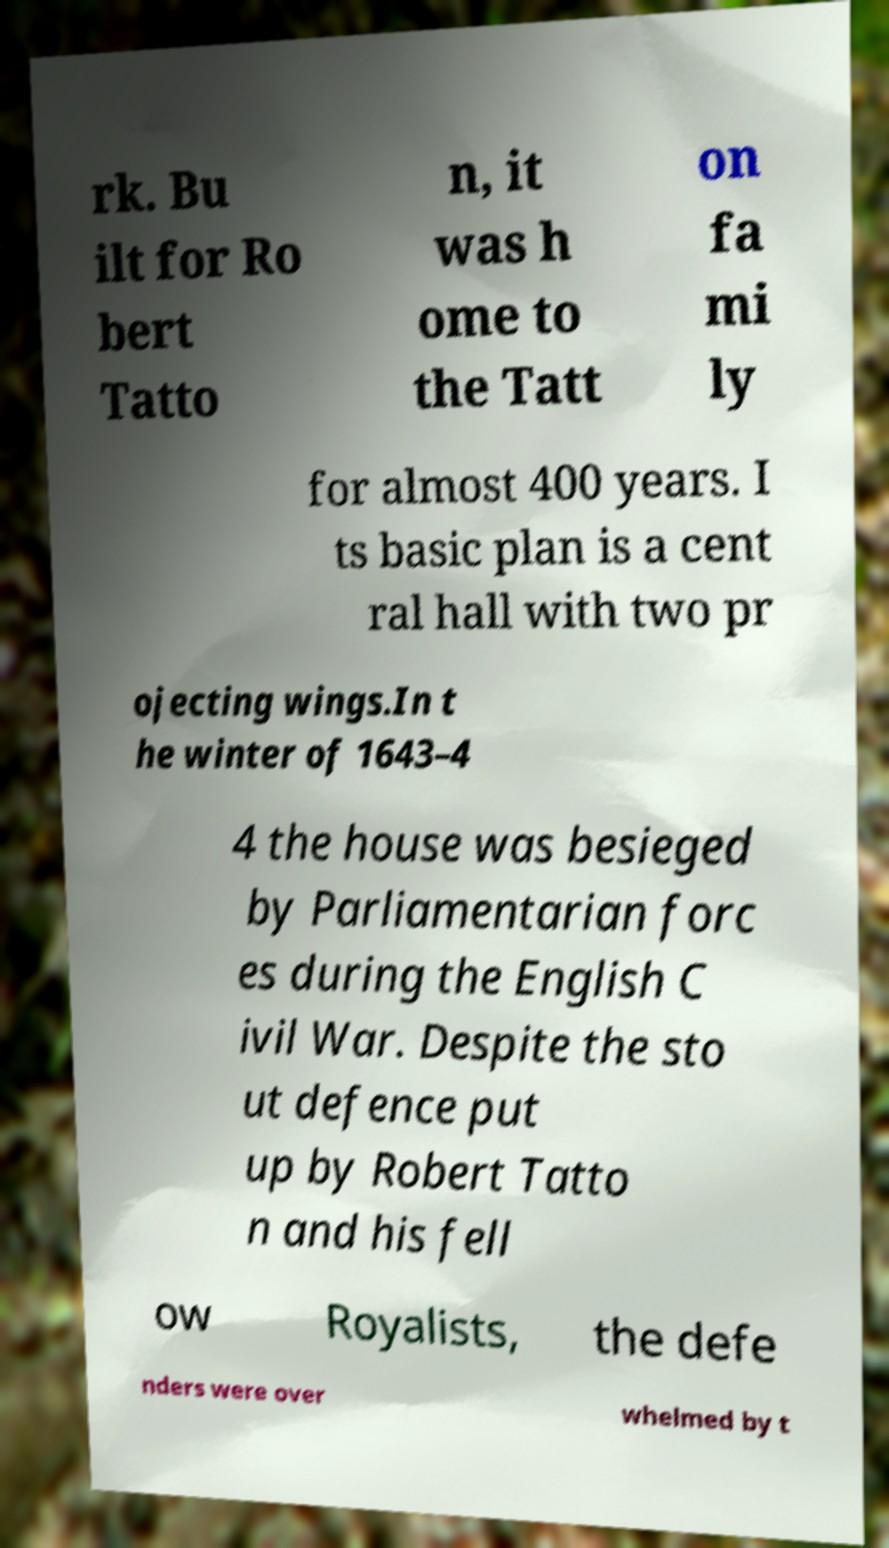There's text embedded in this image that I need extracted. Can you transcribe it verbatim? rk. Bu ilt for Ro bert Tatto n, it was h ome to the Tatt on fa mi ly for almost 400 years. I ts basic plan is a cent ral hall with two pr ojecting wings.In t he winter of 1643–4 4 the house was besieged by Parliamentarian forc es during the English C ivil War. Despite the sto ut defence put up by Robert Tatto n and his fell ow Royalists, the defe nders were over whelmed by t 